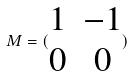<formula> <loc_0><loc_0><loc_500><loc_500>M = ( \begin{matrix} 1 & - 1 \\ 0 & 0 \end{matrix} )</formula> 